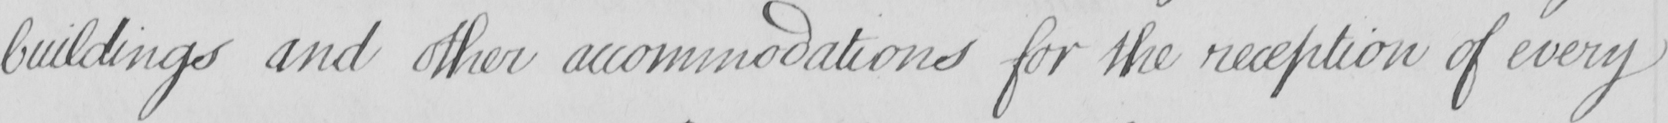What is written in this line of handwriting? buildings and other accommodations for the reception of every 